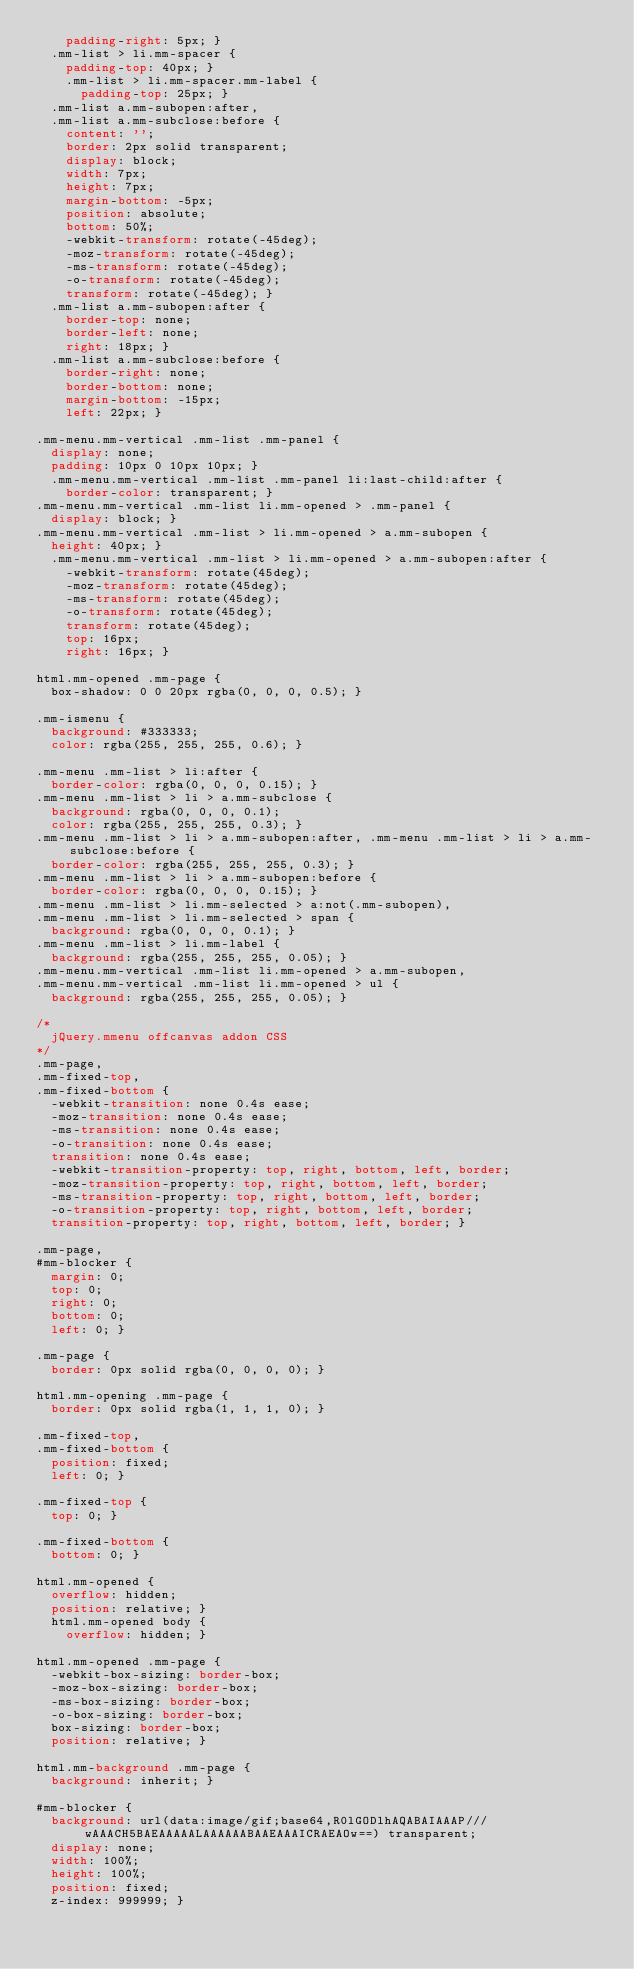Convert code to text. <code><loc_0><loc_0><loc_500><loc_500><_CSS_>    padding-right: 5px; }
  .mm-list > li.mm-spacer {
    padding-top: 40px; }
    .mm-list > li.mm-spacer.mm-label {
      padding-top: 25px; }
  .mm-list a.mm-subopen:after,
  .mm-list a.mm-subclose:before {
    content: '';
    border: 2px solid transparent;
    display: block;
    width: 7px;
    height: 7px;
    margin-bottom: -5px;
    position: absolute;
    bottom: 50%;
    -webkit-transform: rotate(-45deg);
    -moz-transform: rotate(-45deg);
    -ms-transform: rotate(-45deg);
    -o-transform: rotate(-45deg);
    transform: rotate(-45deg); }
  .mm-list a.mm-subopen:after {
    border-top: none;
    border-left: none;
    right: 18px; }
  .mm-list a.mm-subclose:before {
    border-right: none;
    border-bottom: none;
    margin-bottom: -15px;
    left: 22px; }

.mm-menu.mm-vertical .mm-list .mm-panel {
  display: none;
  padding: 10px 0 10px 10px; }
  .mm-menu.mm-vertical .mm-list .mm-panel li:last-child:after {
    border-color: transparent; }
.mm-menu.mm-vertical .mm-list li.mm-opened > .mm-panel {
  display: block; }
.mm-menu.mm-vertical .mm-list > li.mm-opened > a.mm-subopen {
  height: 40px; }
  .mm-menu.mm-vertical .mm-list > li.mm-opened > a.mm-subopen:after {
    -webkit-transform: rotate(45deg);
    -moz-transform: rotate(45deg);
    -ms-transform: rotate(45deg);
    -o-transform: rotate(45deg);
    transform: rotate(45deg);
    top: 16px;
    right: 16px; }

html.mm-opened .mm-page {
  box-shadow: 0 0 20px rgba(0, 0, 0, 0.5); }

.mm-ismenu {
  background: #333333;
  color: rgba(255, 255, 255, 0.6); }

.mm-menu .mm-list > li:after {
  border-color: rgba(0, 0, 0, 0.15); }
.mm-menu .mm-list > li > a.mm-subclose {
  background: rgba(0, 0, 0, 0.1);
  color: rgba(255, 255, 255, 0.3); }
.mm-menu .mm-list > li > a.mm-subopen:after, .mm-menu .mm-list > li > a.mm-subclose:before {
  border-color: rgba(255, 255, 255, 0.3); }
.mm-menu .mm-list > li > a.mm-subopen:before {
  border-color: rgba(0, 0, 0, 0.15); }
.mm-menu .mm-list > li.mm-selected > a:not(.mm-subopen),
.mm-menu .mm-list > li.mm-selected > span {
  background: rgba(0, 0, 0, 0.1); }
.mm-menu .mm-list > li.mm-label {
  background: rgba(255, 255, 255, 0.05); }
.mm-menu.mm-vertical .mm-list li.mm-opened > a.mm-subopen,
.mm-menu.mm-vertical .mm-list li.mm-opened > ul {
  background: rgba(255, 255, 255, 0.05); }

/*
	jQuery.mmenu offcanvas addon CSS
*/
.mm-page,
.mm-fixed-top,
.mm-fixed-bottom {
  -webkit-transition: none 0.4s ease;
  -moz-transition: none 0.4s ease;
  -ms-transition: none 0.4s ease;
  -o-transition: none 0.4s ease;
  transition: none 0.4s ease;
  -webkit-transition-property: top, right, bottom, left, border;
  -moz-transition-property: top, right, bottom, left, border;
  -ms-transition-property: top, right, bottom, left, border;
  -o-transition-property: top, right, bottom, left, border;
  transition-property: top, right, bottom, left, border; }

.mm-page,
#mm-blocker {
  margin: 0;
  top: 0;
  right: 0;
  bottom: 0;
  left: 0; }

.mm-page {
  border: 0px solid rgba(0, 0, 0, 0); }

html.mm-opening .mm-page {
  border: 0px solid rgba(1, 1, 1, 0); }

.mm-fixed-top,
.mm-fixed-bottom {
  position: fixed;
  left: 0; }

.mm-fixed-top {
  top: 0; }

.mm-fixed-bottom {
  bottom: 0; }

html.mm-opened {
  overflow: hidden;
  position: relative; }
  html.mm-opened body {
    overflow: hidden; }

html.mm-opened .mm-page {
  -webkit-box-sizing: border-box;
  -moz-box-sizing: border-box;
  -ms-box-sizing: border-box;
  -o-box-sizing: border-box;
  box-sizing: border-box;
  position: relative; }

html.mm-background .mm-page {
  background: inherit; }

#mm-blocker {
  background: url(data:image/gif;base64,R0lGODlhAQABAIAAAP///wAAACH5BAEAAAAALAAAAAABAAEAAAICRAEAOw==) transparent;
  display: none;
  width: 100%;
  height: 100%;
  position: fixed;
  z-index: 999999; }
</code> 